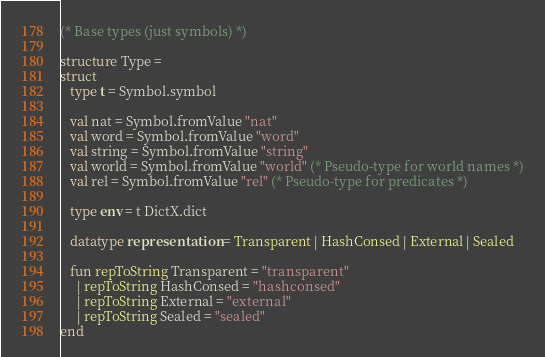<code> <loc_0><loc_0><loc_500><loc_500><_SML_>(* Base types (just symbols) *)

structure Type = 
struct
   type t = Symbol.symbol

   val nat = Symbol.fromValue "nat"
   val word = Symbol.fromValue "word"
   val string = Symbol.fromValue "string"
   val world = Symbol.fromValue "world" (* Pseudo-type for world names *)
   val rel = Symbol.fromValue "rel" (* Pseudo-type for predicates *)

   type env = t DictX.dict

   datatype representation = Transparent | HashConsed | External | Sealed
   
   fun repToString Transparent = "transparent"
     | repToString HashConsed = "hashconsed"
     | repToString External = "external"
     | repToString Sealed = "sealed"
end
</code> 